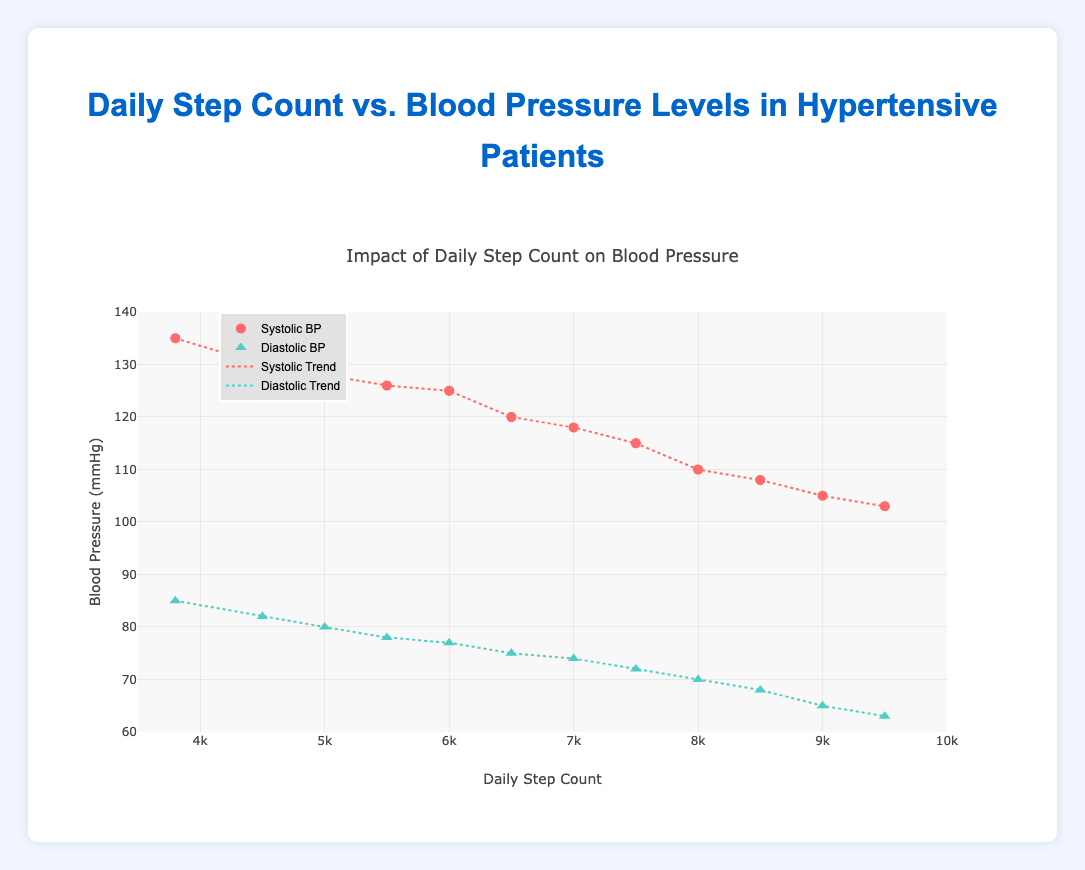What is the title of the figure? The title is typically placed at the top of a plot to describe what it's about. In this case, referring to the figure, the title describes the comparison.
Answer: Daily Step Count vs. Blood Pressure Levels in Hypertensive Patients What is the range of the Daily Step Count axis? The Daily Step Count axis is the x-axis, and its range shows the minimum and maximum values for daily steps. It is labeled and the minimum value is 3500 and maximum is 10000.
Answer: 3500 to 10000 How many data points are there for Systolic BP? Each patient's data point is plotted separately on the graph. By counting the number of Systolic BP data points, we can determine how many there are. There are 12 patients, thus 12 data points.
Answer: 12 Which patient has the highest Systolic BP? To find this, look for the patient whose Systolic BP value is the highest among the plotted data points. Patient P001 has a Systolic BP of 135, which is the highest.
Answer: P001 Is the Diastolic BP trend line increasing or decreasing with respect to Daily Step Count? The trend line for Diastolic BP can be observed in the plot. It shows whether the values increase or decrease as the number of steps increases. The Diastolic BP trend line is decreasing.
Answer: Decreasing What's the average number of steps taken by patients whose Systolic BP is below 120? First, identify the patients with Systolic BP below 120 (P006, P007, P008, P009, P010, P011, P012) and then calculate the average of their Daily Step Counts: (6500 + 7000 + 7500 + 8000 + 8500 + 9000 + 9500) / 7. Calculation: 56000 / 7 = 8000.
Answer: 8000 Which data point represents the patient with the lowest Diastolic BP? To find the lowest Diastolic BP value, look at the data points and find the one with the smallest Diastolic BP. The lowest value is 63 for patient P012.
Answer: P012 Between which Daily Step Count values does the Systolic BP trend cross the 120 mmHg mark? To determine this, find where the Systolic BP trend line intersects the 120 mmHg value on the y-axis and check the corresponding Daily Step Count values. It's around 6500 steps.
Answer: Around 6500 Do more steps generally lead to lower Blood Pressure levels? Analyze the trend lines and scatter plots. Both Systolic and Diastolic BP trend lines are decreasing as Daily Step Count increases, indicating that more steps generally correlate with lower BP levels.
Answer: Yes 